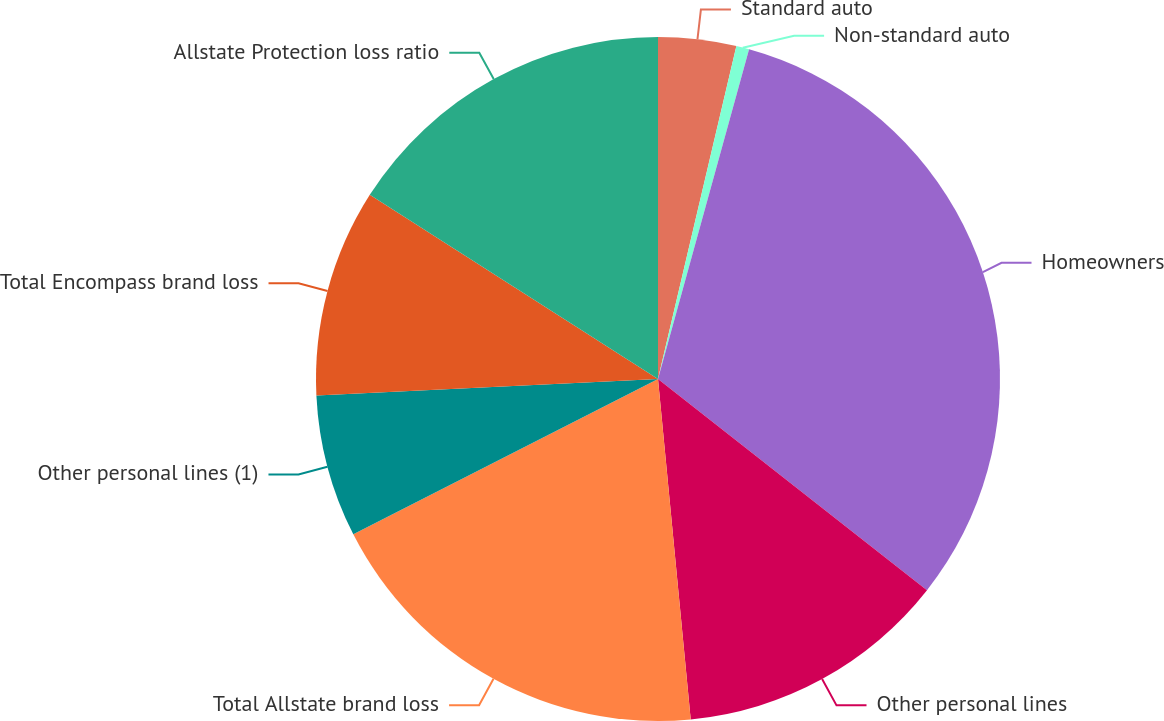Convert chart. <chart><loc_0><loc_0><loc_500><loc_500><pie_chart><fcel>Standard auto<fcel>Non-standard auto<fcel>Homeowners<fcel>Other personal lines<fcel>Total Allstate brand loss<fcel>Other personal lines (1)<fcel>Total Encompass brand loss<fcel>Allstate Protection loss ratio<nl><fcel>3.68%<fcel>0.61%<fcel>31.3%<fcel>12.88%<fcel>19.02%<fcel>6.74%<fcel>9.81%<fcel>15.95%<nl></chart> 